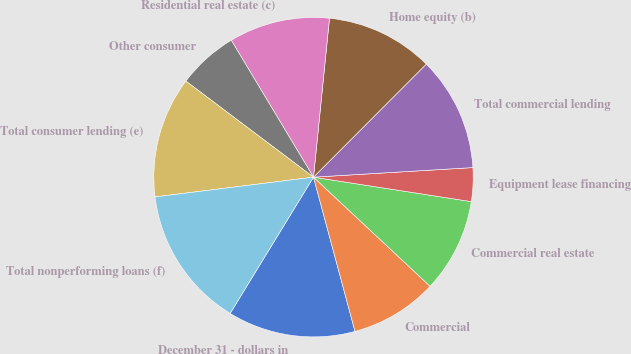<chart> <loc_0><loc_0><loc_500><loc_500><pie_chart><fcel>December 31 - dollars in<fcel>Commercial<fcel>Commercial real estate<fcel>Equipment lease financing<fcel>Total commercial lending<fcel>Home equity (b)<fcel>Residential real estate (c)<fcel>Other consumer<fcel>Total consumer lending (e)<fcel>Total nonperforming loans (f)<nl><fcel>12.92%<fcel>8.84%<fcel>9.52%<fcel>3.4%<fcel>11.56%<fcel>10.88%<fcel>10.2%<fcel>6.12%<fcel>12.24%<fcel>14.28%<nl></chart> 